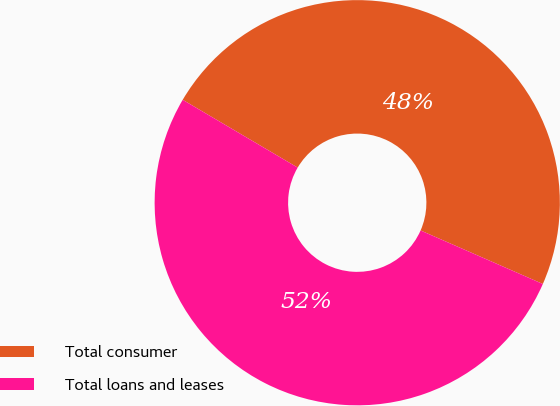Convert chart to OTSL. <chart><loc_0><loc_0><loc_500><loc_500><pie_chart><fcel>Total consumer<fcel>Total loans and leases<nl><fcel>48.09%<fcel>51.91%<nl></chart> 